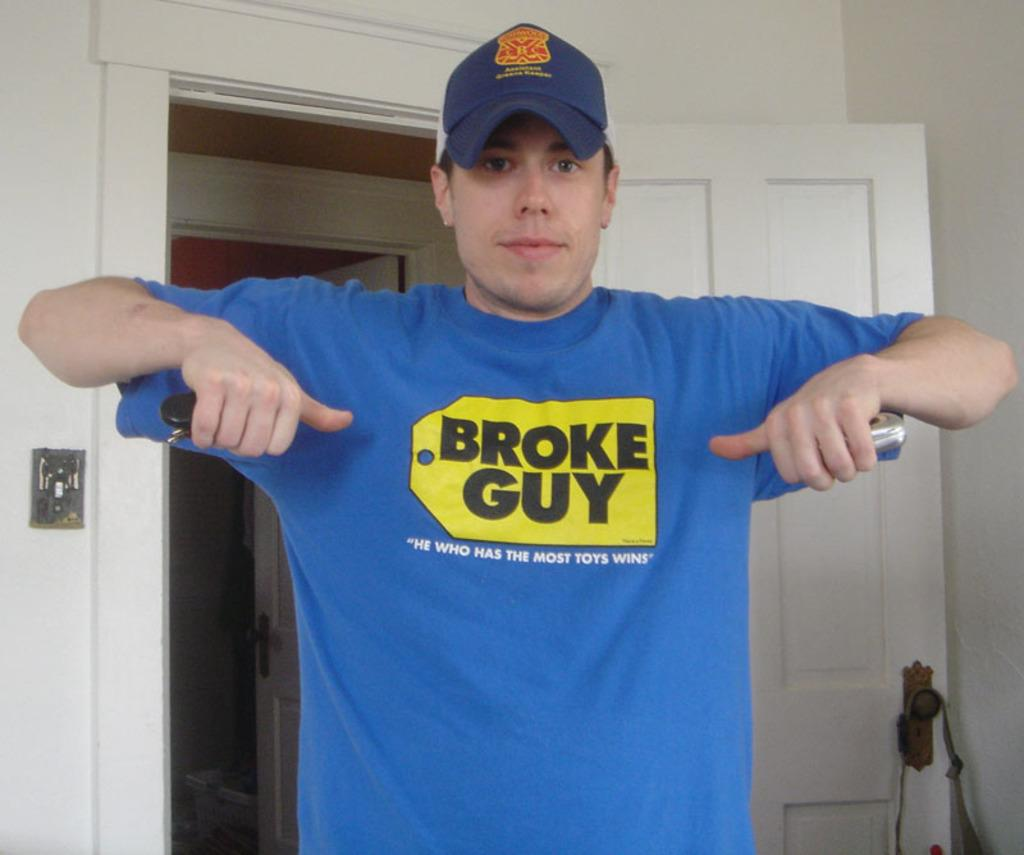<image>
Summarize the visual content of the image. A man wearing a blue shirt that says Broke Guy in a Best Buy logo. 